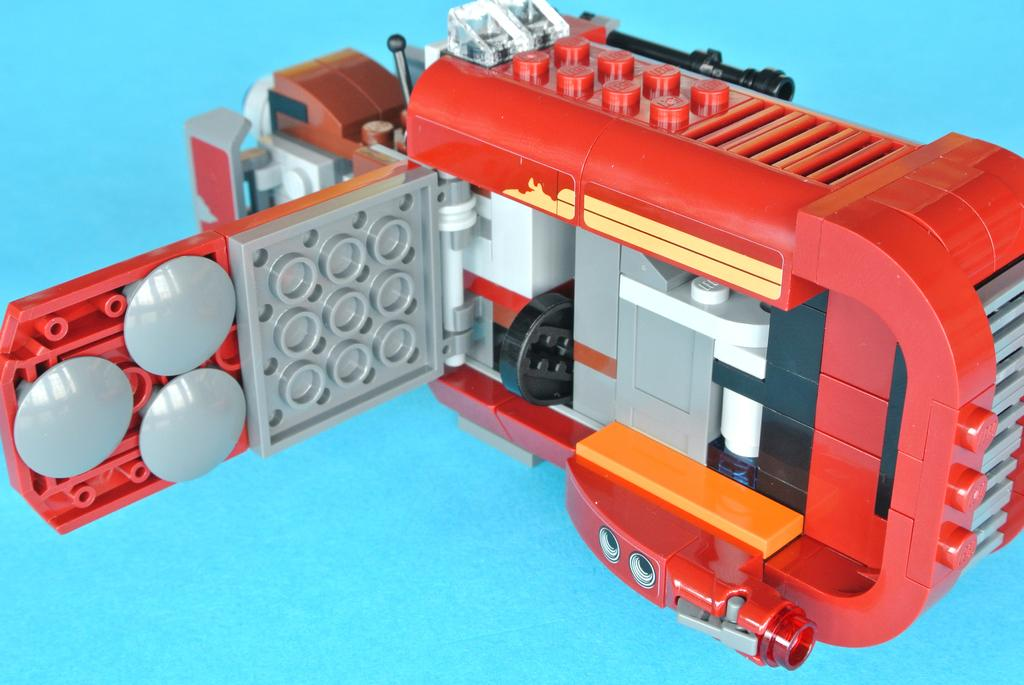What is the color of the object in the image? The object in the image is red and grey. What color can be seen in the background of the image? Blue color is visible in the background of the image. How many pizzas are being prepared in the image? There are no pizzas or any indication of food preparation in the image. What type of dirt can be seen on the object in the image? There is no dirt visible on the object in the image; it appears to be clean. 